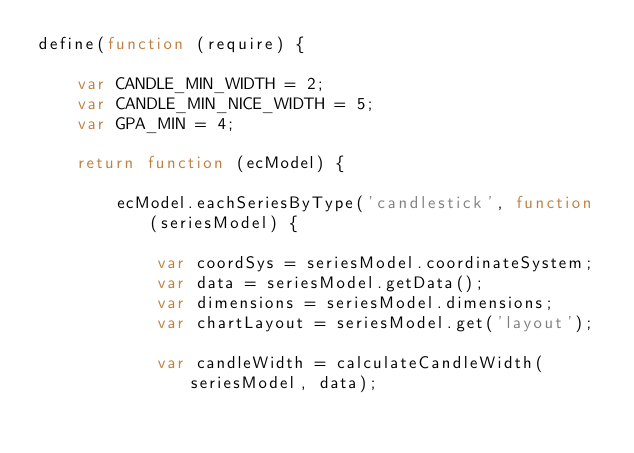Convert code to text. <code><loc_0><loc_0><loc_500><loc_500><_JavaScript_>define(function (require) {

    var CANDLE_MIN_WIDTH = 2;
    var CANDLE_MIN_NICE_WIDTH = 5;
    var GPA_MIN = 4;

    return function (ecModel) {

        ecModel.eachSeriesByType('candlestick', function (seriesModel) {

            var coordSys = seriesModel.coordinateSystem;
            var data = seriesModel.getData();
            var dimensions = seriesModel.dimensions;
            var chartLayout = seriesModel.get('layout');

            var candleWidth = calculateCandleWidth(seriesModel, data);
</code> 